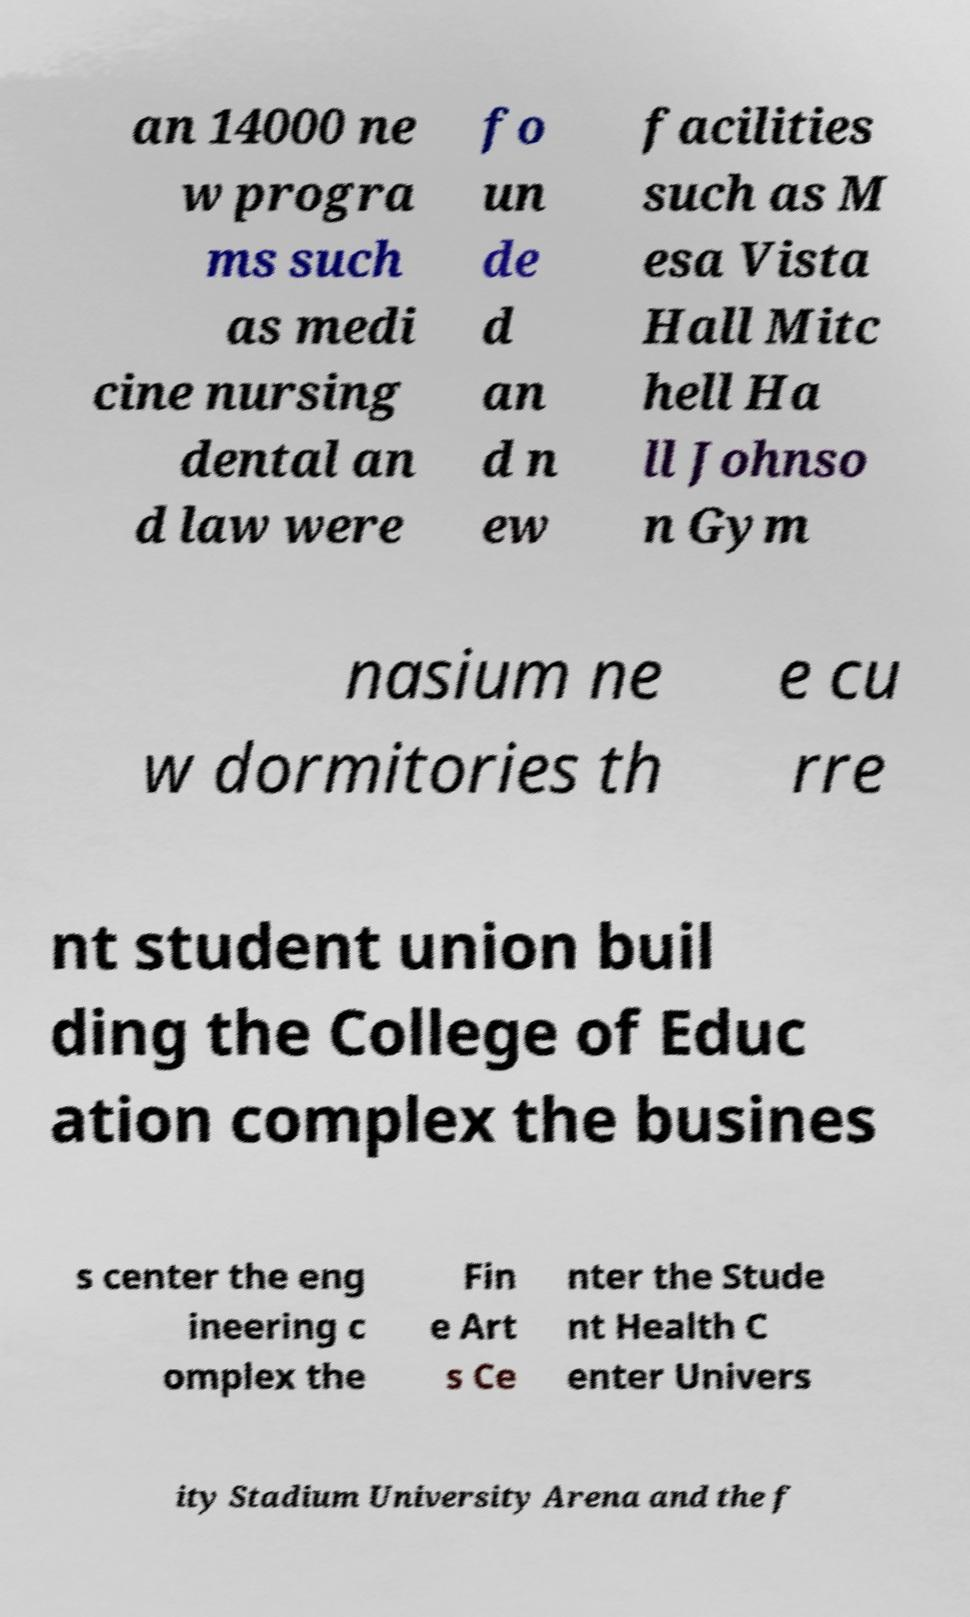Can you read and provide the text displayed in the image?This photo seems to have some interesting text. Can you extract and type it out for me? an 14000 ne w progra ms such as medi cine nursing dental an d law were fo un de d an d n ew facilities such as M esa Vista Hall Mitc hell Ha ll Johnso n Gym nasium ne w dormitories th e cu rre nt student union buil ding the College of Educ ation complex the busines s center the eng ineering c omplex the Fin e Art s Ce nter the Stude nt Health C enter Univers ity Stadium University Arena and the f 